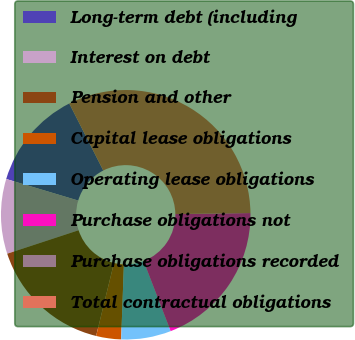Convert chart to OTSL. <chart><loc_0><loc_0><loc_500><loc_500><pie_chart><fcel>Long-term debt (including<fcel>Interest on debt<fcel>Pension and other<fcel>Capital lease obligations<fcel>Operating lease obligations<fcel>Purchase obligations not<fcel>Purchase obligations recorded<fcel>Total contractual obligations<nl><fcel>12.9%<fcel>9.68%<fcel>16.13%<fcel>3.23%<fcel>6.45%<fcel>19.35%<fcel>0.0%<fcel>32.25%<nl></chart> 